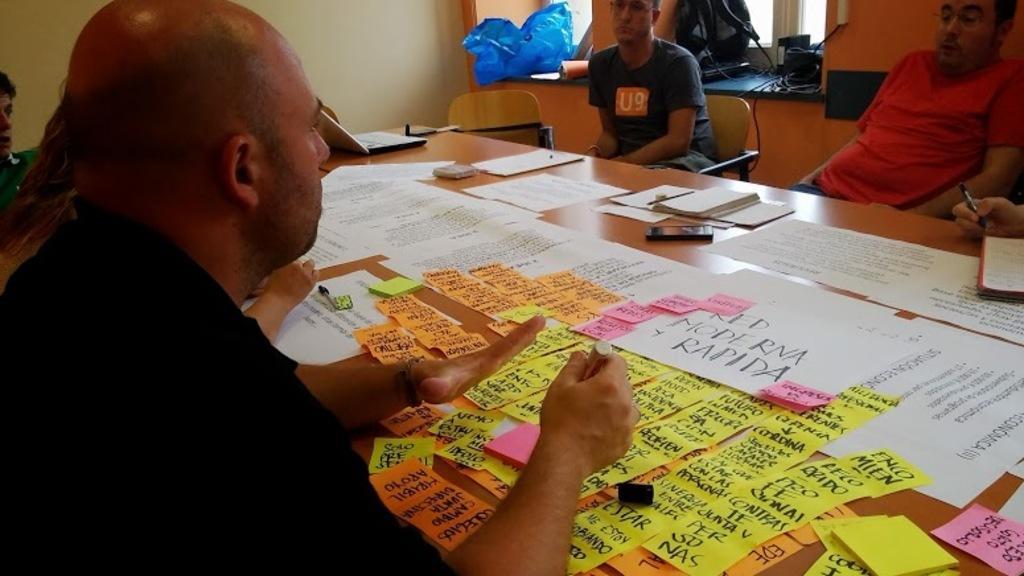Could you give a brief overview of what you see in this image? In this image, we can see a table, on that table there are some papers kept, there are some people sitting on the chairs around the table, we can see windows. 